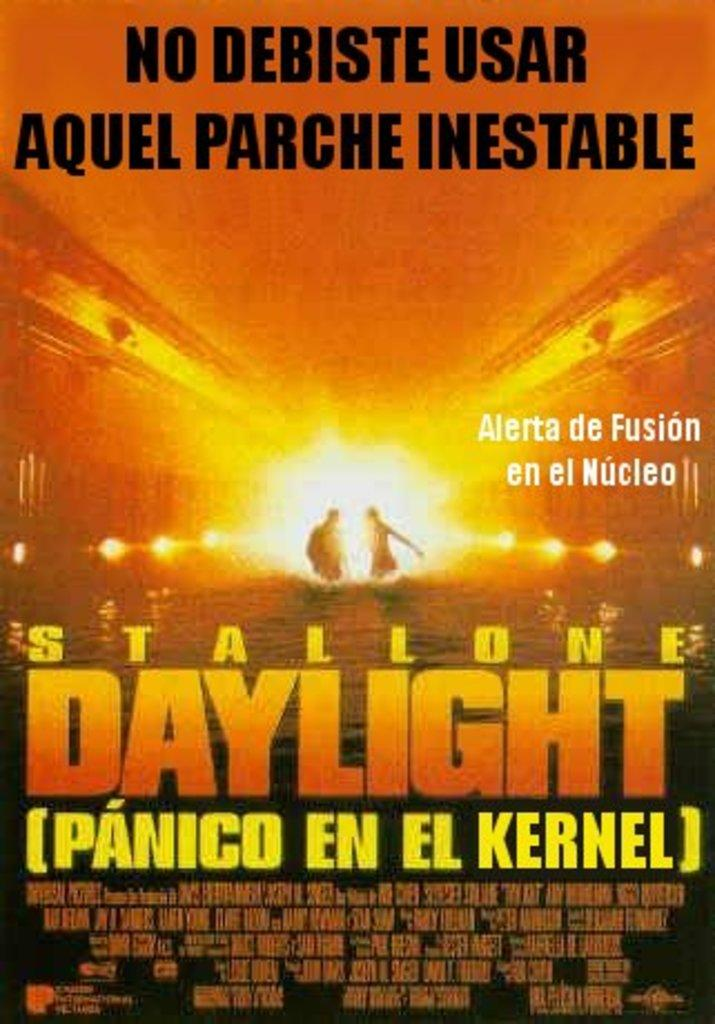Provide a one-sentence caption for the provided image. A poster for the film Daylight starring Stallone. 